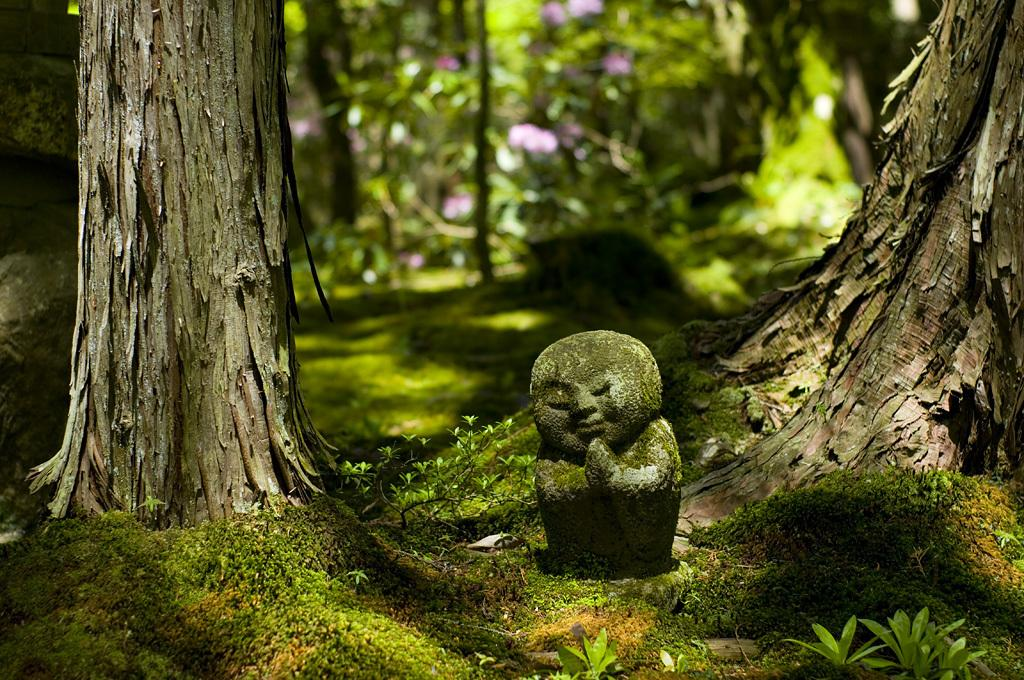What type of vegetation can be seen in the image? There are trees in the image. What is the material of the object that appears to be carved? There is a carved stone in the image. What covers the ground in the image? Grass is present on the ground in the image. What type of milk is being poured on the trees in the image? There is no milk present in the image; it features trees, a carved stone, and grass. Can you see any writing on the trees in the image? There is no writing visible on the trees in the image. 